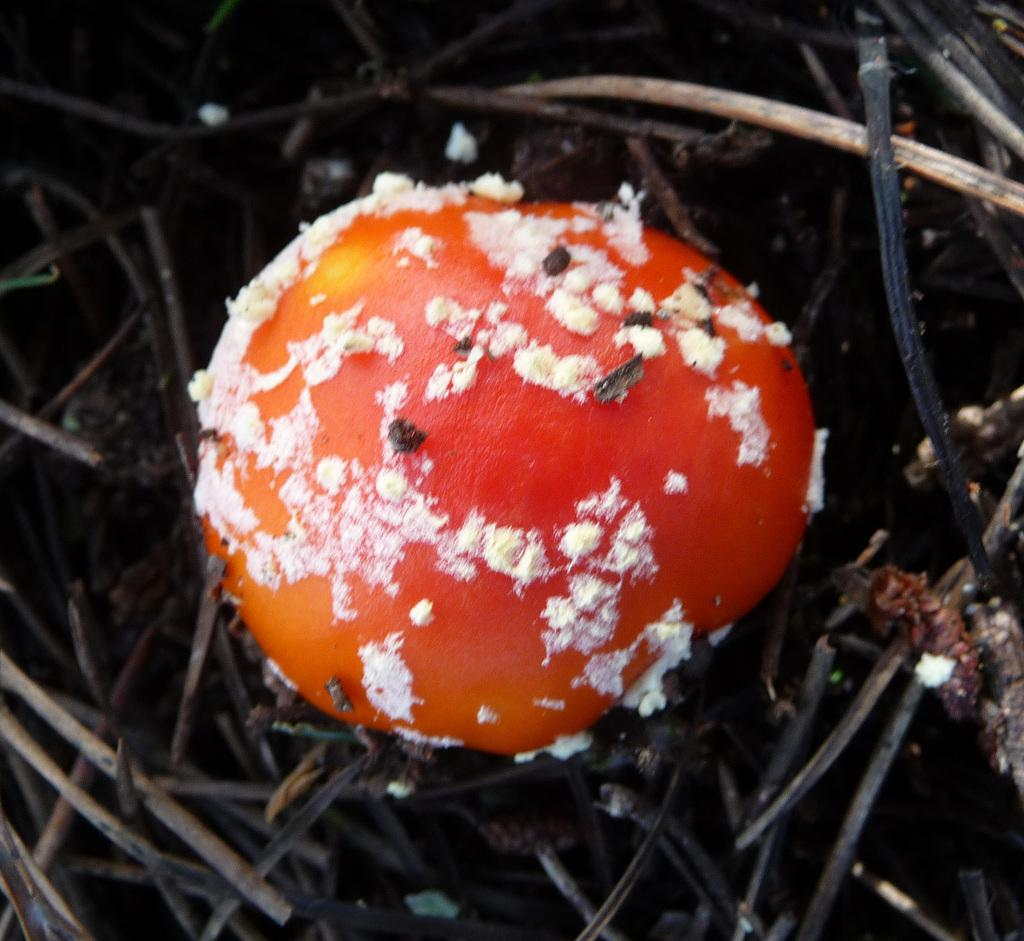What type of fungi can be seen in the image? There are mushrooms in the image. What material are the sticks made of in the image? The sticks in the image are made of wood. What type of disgust can be seen on the mushrooms in the image? There is no indication of disgust in the image; it simply shows mushrooms and wooden sticks. What type of polish is used on the wooden sticks in the image? There is no information about any polish being used on the wooden sticks in the image. 